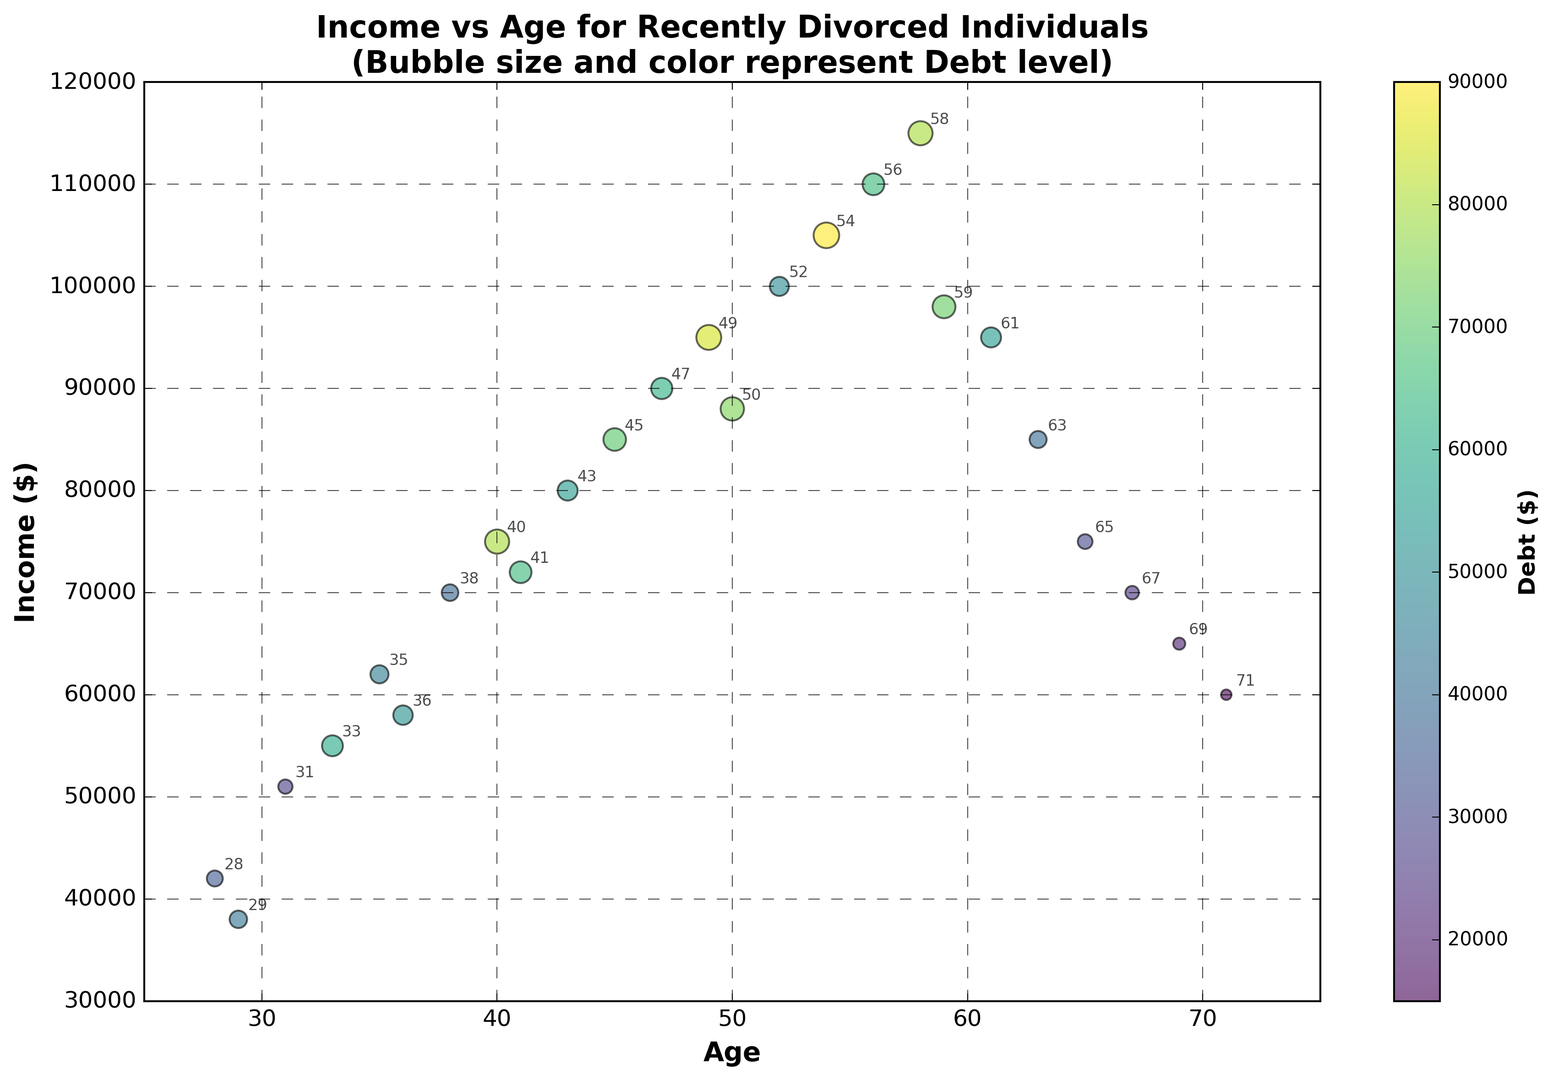What's the average income of individuals aged 50 and above? To find the average, first sum the incomes: (88000 + 100000 + 105000 + 110000 + 115000 + 98000 + 95000 + 85000 + 75000 + 70000 + 65000 + 60000). This gives us a sum of 1065000. There are 12 individuals aged 50 and above, so divide the sum by 12: 1065000 / 12.
Answer: 88750 Which age group has the highest level of debt? By looking at the scatter plot, identify the data point with the largest bubble size and/or deepest color. The age 54 has the biggest bubble and the most prominent color indicating the highest debt level of 90000.
Answer: 54 Who has the same debt level but different incomes? Observe the scatter plot and identify data points with similarly-sized bubbles. For instance, both individuals aged 36 and 58 have debt levels around 80000, but their incomes are different (58000 and 115000 respectively).
Answer: 36 & 58 What is the difference in income between the oldest and youngest individual? Identify the incomes of the oldest (71 years, 60000) and the youngest (28 years, 42000) individuals. Subtract the income of the youngest from the oldest: 60000 - 42000.
Answer: 18000 Compare the debt levels of individuals aged 40 and 45. Who has more debt? Check the scatter plot for the bubble size and color at these ages. The 40-year-old has a debt of 80000, and the 45-year-old has a debt of 70000. The 40-year-old has more debt.
Answer: 40 What is the income range of individuals under 40? Identify the incomes of all individuals aged 39 and younger: 42000, 38000, 51000, 55000, 62000, 58000, 70000. The lowest income is 38000, and the highest is 70000, giving the income range (70000 - 38000).
Answer: 32000 Which two age groups have the most similar incomes but different debt levels? Look at the scatter plot for data points that are close vertically but have differently sized/colorful bubbles. Ages 38 and 41 both have similar incomes (70000 & 72000 respectively), but the debt levels are 38000 for 38 and 65000 for 41.
Answer: 38 & 41 